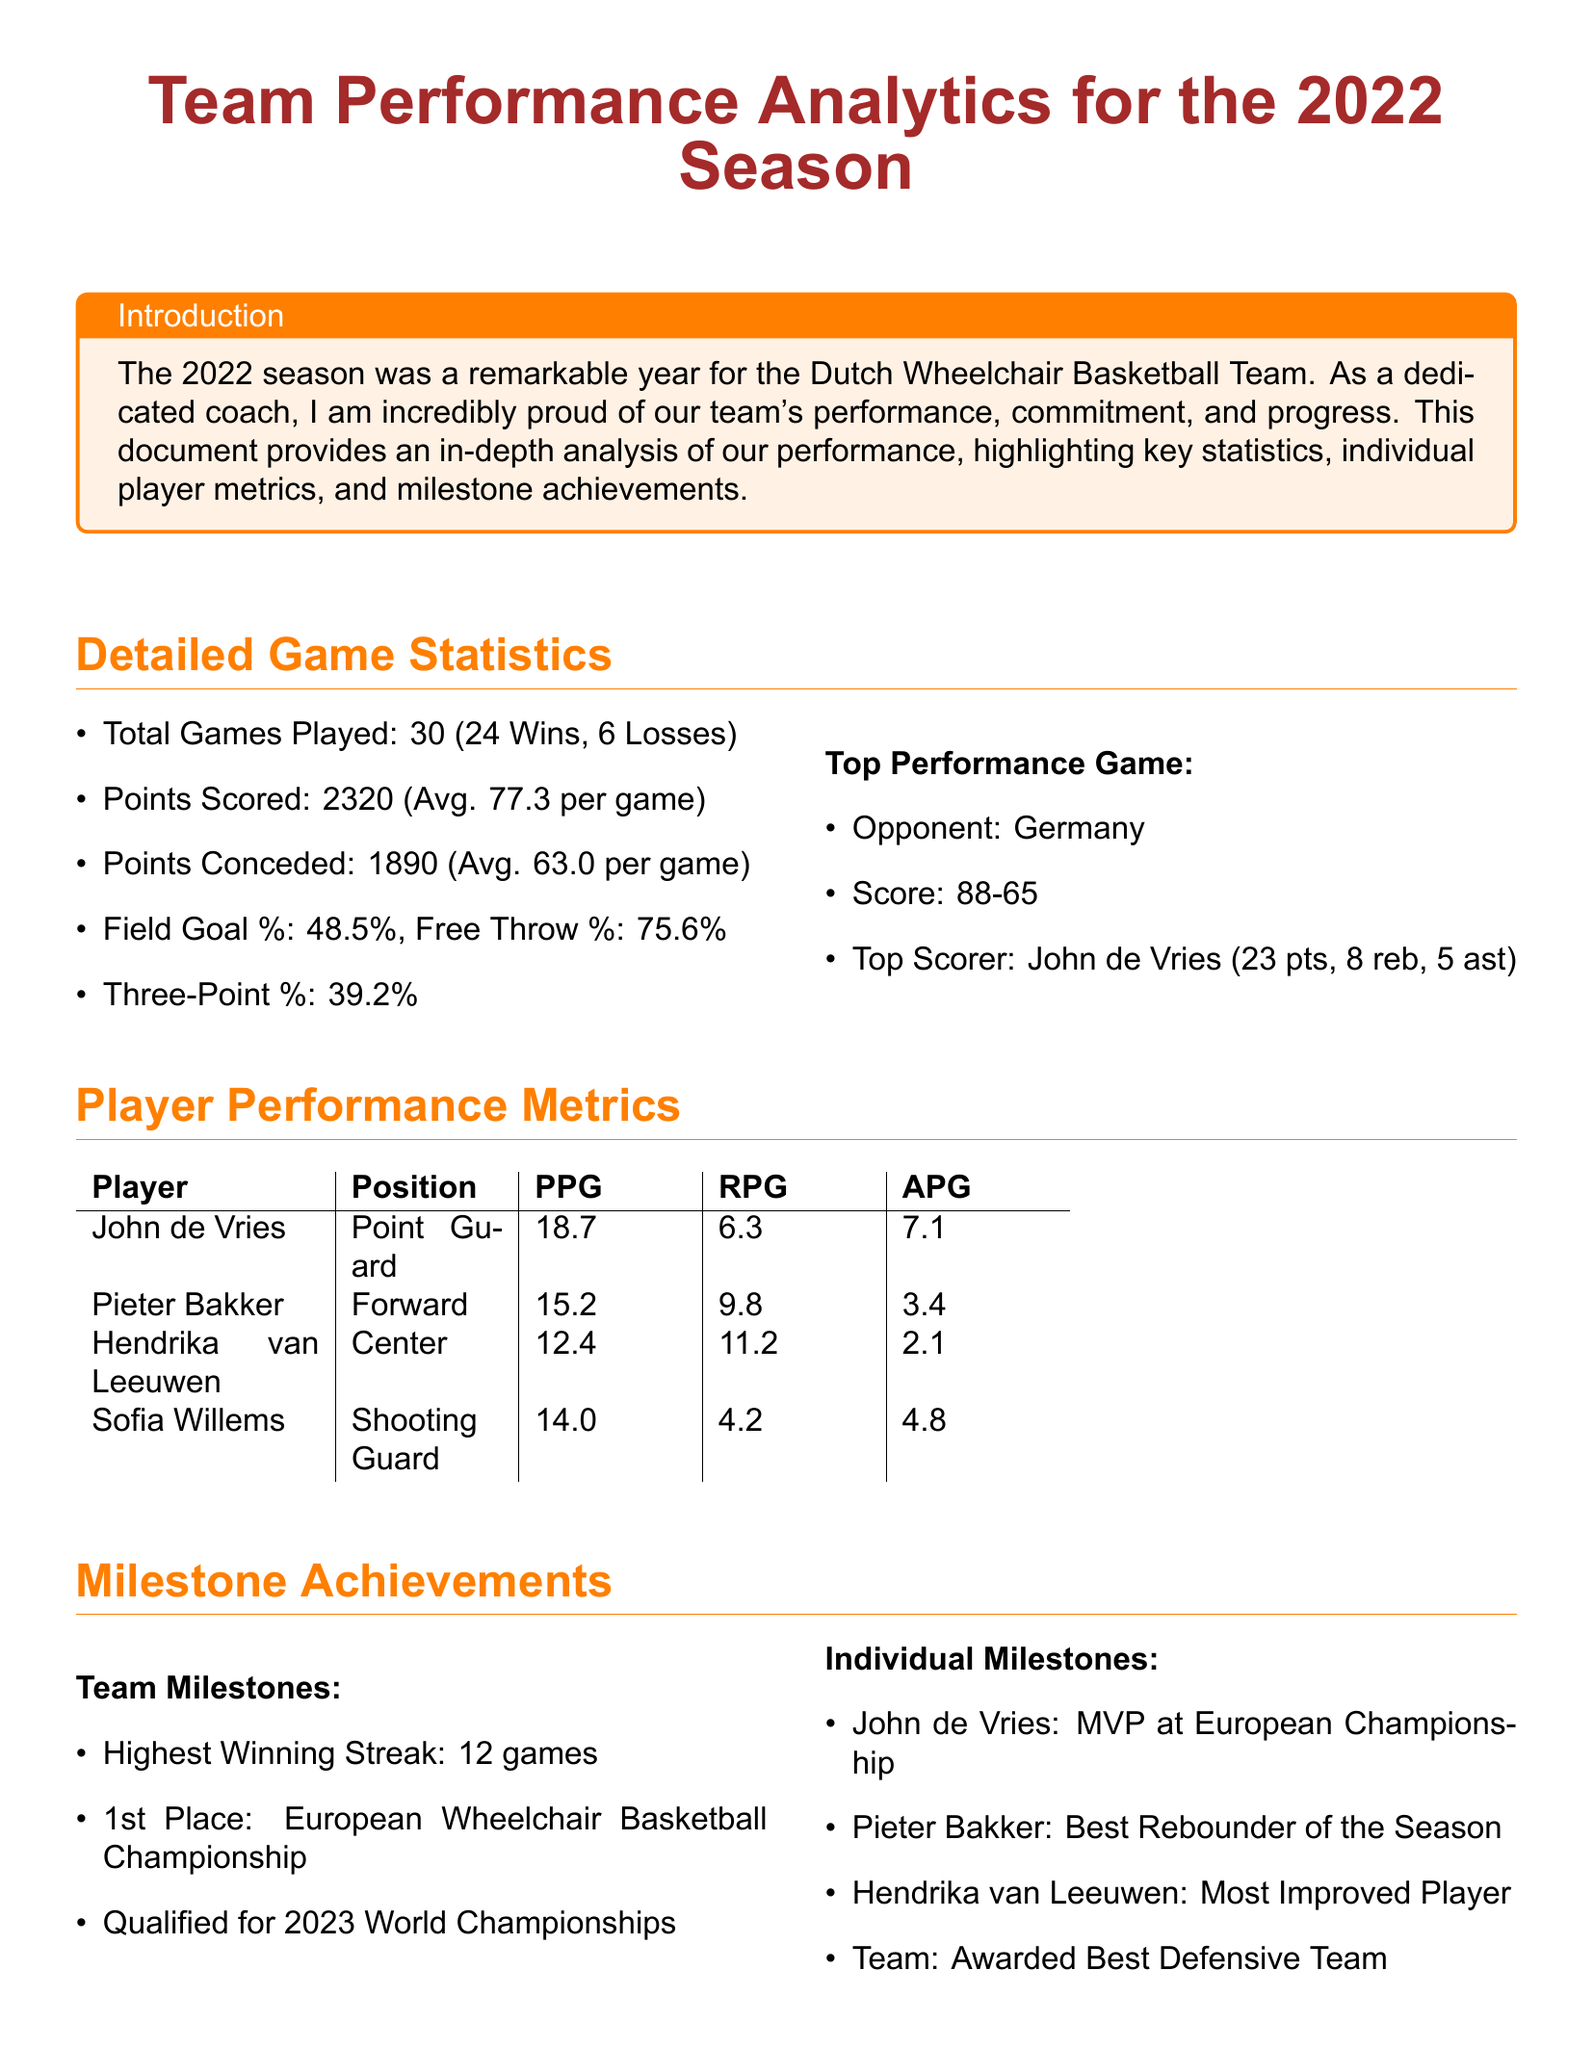what was the total number of games played? The total number of games played is explicitly stated in the document as part of the detailed game statistics.
Answer: 30 how many points did the team score on average per game? The average points scored per game is provided in the detailed game statistics section of the document.
Answer: 77.3 who was the top scorer in the game against Germany? The name and performance details of the top scorer during the best performance game are mentioned in the document.
Answer: John de Vries what position does Pieter Bakker play? The document specifies the positions of the players in the player performance metrics table.
Answer: Forward what is the highest winning streak recorded by the team? The highest winning streak is detailed in the milestone achievements section of the document.
Answer: 12 games which award was John de Vries given at the European Championship? The individual milestone achievements highlight specific accolades received by players, including John de Vries.
Answer: MVP how many points were conceded by the team on average per game? The average points conceded per game is clearly mentioned in the detailed game statistics section of the document.
Answer: 63.0 which position did Hendrika van Leeuwen achieve recognition for? The document outlines individual milestones, including recognition for players, specifically mentioning Hendrika van Leeuwen’s achievement.
Answer: Most Improved Player how many free throws did the team convert on average? The average free throw percentage provided gives insight into the team's shooting effectiveness during games, which is in the detailed game statistics.
Answer: 75.6% 